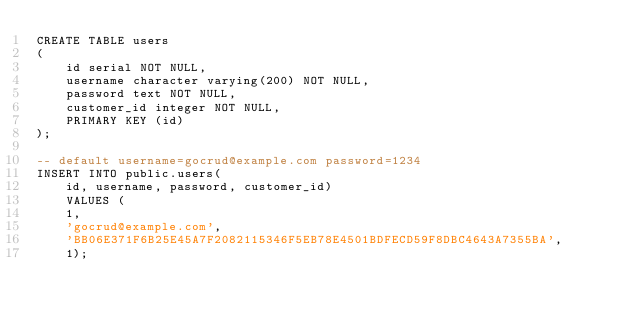<code> <loc_0><loc_0><loc_500><loc_500><_SQL_>CREATE TABLE users
(
    id serial NOT NULL,
    username character varying(200) NOT NULL,
    password text NOT NULL,
    customer_id integer NOT NULL,
    PRIMARY KEY (id)
);

-- default username=gocrud@example.com password=1234
INSERT INTO public.users(
	id, username, password, customer_id)
	VALUES (
    1, 
    'gocrud@example.com', 
    'BB06E371F6B25E45A7F2082115346F5EB78E4501BDFECD59F8DBC4643A7355BA', 
    1);</code> 